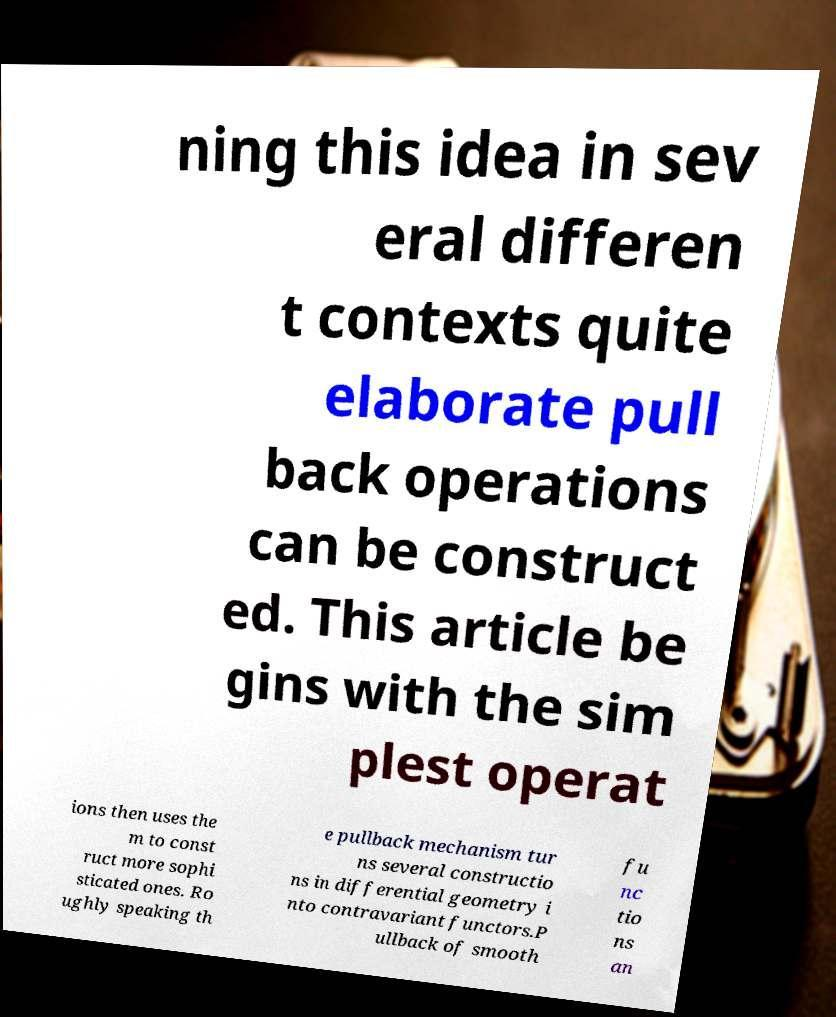Can you accurately transcribe the text from the provided image for me? ning this idea in sev eral differen t contexts quite elaborate pull back operations can be construct ed. This article be gins with the sim plest operat ions then uses the m to const ruct more sophi sticated ones. Ro ughly speaking th e pullback mechanism tur ns several constructio ns in differential geometry i nto contravariant functors.P ullback of smooth fu nc tio ns an 